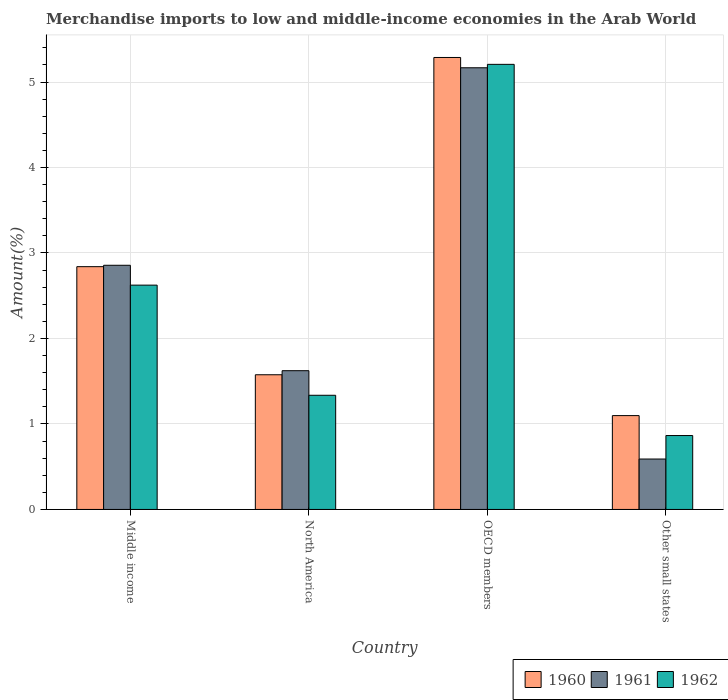How many different coloured bars are there?
Your response must be concise. 3. How many groups of bars are there?
Your answer should be compact. 4. Are the number of bars per tick equal to the number of legend labels?
Your answer should be very brief. Yes. Are the number of bars on each tick of the X-axis equal?
Offer a very short reply. Yes. What is the label of the 2nd group of bars from the left?
Make the answer very short. North America. What is the percentage of amount earned from merchandise imports in 1961 in Other small states?
Make the answer very short. 0.59. Across all countries, what is the maximum percentage of amount earned from merchandise imports in 1961?
Your response must be concise. 5.17. Across all countries, what is the minimum percentage of amount earned from merchandise imports in 1960?
Give a very brief answer. 1.1. In which country was the percentage of amount earned from merchandise imports in 1962 minimum?
Provide a short and direct response. Other small states. What is the total percentage of amount earned from merchandise imports in 1960 in the graph?
Your answer should be compact. 10.8. What is the difference between the percentage of amount earned from merchandise imports in 1961 in Middle income and that in Other small states?
Ensure brevity in your answer.  2.27. What is the difference between the percentage of amount earned from merchandise imports in 1961 in OECD members and the percentage of amount earned from merchandise imports in 1960 in Other small states?
Your answer should be compact. 4.07. What is the average percentage of amount earned from merchandise imports in 1961 per country?
Offer a very short reply. 2.56. What is the difference between the percentage of amount earned from merchandise imports of/in 1960 and percentage of amount earned from merchandise imports of/in 1962 in OECD members?
Offer a very short reply. 0.08. In how many countries, is the percentage of amount earned from merchandise imports in 1962 greater than 0.6000000000000001 %?
Provide a succinct answer. 4. What is the ratio of the percentage of amount earned from merchandise imports in 1962 in North America to that in OECD members?
Make the answer very short. 0.26. What is the difference between the highest and the second highest percentage of amount earned from merchandise imports in 1960?
Make the answer very short. -1.26. What is the difference between the highest and the lowest percentage of amount earned from merchandise imports in 1961?
Your answer should be very brief. 4.58. In how many countries, is the percentage of amount earned from merchandise imports in 1961 greater than the average percentage of amount earned from merchandise imports in 1961 taken over all countries?
Provide a short and direct response. 2. Is the sum of the percentage of amount earned from merchandise imports in 1962 in Middle income and North America greater than the maximum percentage of amount earned from merchandise imports in 1960 across all countries?
Ensure brevity in your answer.  No. What does the 3rd bar from the right in Middle income represents?
Your answer should be very brief. 1960. Is it the case that in every country, the sum of the percentage of amount earned from merchandise imports in 1962 and percentage of amount earned from merchandise imports in 1961 is greater than the percentage of amount earned from merchandise imports in 1960?
Ensure brevity in your answer.  Yes. How many bars are there?
Offer a terse response. 12. Are all the bars in the graph horizontal?
Your response must be concise. No. What is the difference between two consecutive major ticks on the Y-axis?
Provide a succinct answer. 1. Are the values on the major ticks of Y-axis written in scientific E-notation?
Your answer should be very brief. No. Does the graph contain any zero values?
Your answer should be very brief. No. Does the graph contain grids?
Offer a terse response. Yes. Where does the legend appear in the graph?
Your answer should be compact. Bottom right. How many legend labels are there?
Provide a succinct answer. 3. What is the title of the graph?
Your response must be concise. Merchandise imports to low and middle-income economies in the Arab World. Does "2004" appear as one of the legend labels in the graph?
Offer a terse response. No. What is the label or title of the Y-axis?
Make the answer very short. Amount(%). What is the Amount(%) in 1960 in Middle income?
Make the answer very short. 2.84. What is the Amount(%) of 1961 in Middle income?
Make the answer very short. 2.86. What is the Amount(%) of 1962 in Middle income?
Offer a very short reply. 2.62. What is the Amount(%) of 1960 in North America?
Offer a terse response. 1.58. What is the Amount(%) in 1961 in North America?
Your answer should be compact. 1.62. What is the Amount(%) of 1962 in North America?
Give a very brief answer. 1.34. What is the Amount(%) of 1960 in OECD members?
Give a very brief answer. 5.29. What is the Amount(%) of 1961 in OECD members?
Ensure brevity in your answer.  5.17. What is the Amount(%) of 1962 in OECD members?
Your answer should be very brief. 5.21. What is the Amount(%) in 1960 in Other small states?
Make the answer very short. 1.1. What is the Amount(%) in 1961 in Other small states?
Your answer should be very brief. 0.59. What is the Amount(%) in 1962 in Other small states?
Ensure brevity in your answer.  0.86. Across all countries, what is the maximum Amount(%) of 1960?
Your response must be concise. 5.29. Across all countries, what is the maximum Amount(%) in 1961?
Make the answer very short. 5.17. Across all countries, what is the maximum Amount(%) of 1962?
Offer a very short reply. 5.21. Across all countries, what is the minimum Amount(%) in 1960?
Make the answer very short. 1.1. Across all countries, what is the minimum Amount(%) in 1961?
Make the answer very short. 0.59. Across all countries, what is the minimum Amount(%) of 1962?
Offer a very short reply. 0.86. What is the total Amount(%) of 1960 in the graph?
Keep it short and to the point. 10.8. What is the total Amount(%) of 1961 in the graph?
Offer a very short reply. 10.24. What is the total Amount(%) in 1962 in the graph?
Keep it short and to the point. 10.03. What is the difference between the Amount(%) in 1960 in Middle income and that in North America?
Your response must be concise. 1.26. What is the difference between the Amount(%) of 1961 in Middle income and that in North America?
Give a very brief answer. 1.23. What is the difference between the Amount(%) of 1962 in Middle income and that in North America?
Ensure brevity in your answer.  1.29. What is the difference between the Amount(%) in 1960 in Middle income and that in OECD members?
Offer a very short reply. -2.45. What is the difference between the Amount(%) in 1961 in Middle income and that in OECD members?
Your answer should be compact. -2.31. What is the difference between the Amount(%) in 1962 in Middle income and that in OECD members?
Provide a short and direct response. -2.58. What is the difference between the Amount(%) in 1960 in Middle income and that in Other small states?
Provide a succinct answer. 1.74. What is the difference between the Amount(%) of 1961 in Middle income and that in Other small states?
Ensure brevity in your answer.  2.27. What is the difference between the Amount(%) of 1962 in Middle income and that in Other small states?
Give a very brief answer. 1.76. What is the difference between the Amount(%) in 1960 in North America and that in OECD members?
Offer a terse response. -3.71. What is the difference between the Amount(%) in 1961 in North America and that in OECD members?
Offer a terse response. -3.54. What is the difference between the Amount(%) in 1962 in North America and that in OECD members?
Give a very brief answer. -3.87. What is the difference between the Amount(%) of 1960 in North America and that in Other small states?
Make the answer very short. 0.48. What is the difference between the Amount(%) of 1961 in North America and that in Other small states?
Your answer should be compact. 1.03. What is the difference between the Amount(%) of 1962 in North America and that in Other small states?
Offer a very short reply. 0.47. What is the difference between the Amount(%) of 1960 in OECD members and that in Other small states?
Your answer should be compact. 4.19. What is the difference between the Amount(%) in 1961 in OECD members and that in Other small states?
Ensure brevity in your answer.  4.58. What is the difference between the Amount(%) of 1962 in OECD members and that in Other small states?
Offer a terse response. 4.34. What is the difference between the Amount(%) in 1960 in Middle income and the Amount(%) in 1961 in North America?
Your answer should be compact. 1.22. What is the difference between the Amount(%) of 1960 in Middle income and the Amount(%) of 1962 in North America?
Your answer should be compact. 1.5. What is the difference between the Amount(%) of 1961 in Middle income and the Amount(%) of 1962 in North America?
Give a very brief answer. 1.52. What is the difference between the Amount(%) in 1960 in Middle income and the Amount(%) in 1961 in OECD members?
Make the answer very short. -2.33. What is the difference between the Amount(%) in 1960 in Middle income and the Amount(%) in 1962 in OECD members?
Make the answer very short. -2.37. What is the difference between the Amount(%) in 1961 in Middle income and the Amount(%) in 1962 in OECD members?
Offer a terse response. -2.35. What is the difference between the Amount(%) of 1960 in Middle income and the Amount(%) of 1961 in Other small states?
Keep it short and to the point. 2.25. What is the difference between the Amount(%) in 1960 in Middle income and the Amount(%) in 1962 in Other small states?
Your answer should be very brief. 1.98. What is the difference between the Amount(%) of 1961 in Middle income and the Amount(%) of 1962 in Other small states?
Your response must be concise. 1.99. What is the difference between the Amount(%) of 1960 in North America and the Amount(%) of 1961 in OECD members?
Provide a short and direct response. -3.59. What is the difference between the Amount(%) in 1960 in North America and the Amount(%) in 1962 in OECD members?
Your answer should be compact. -3.63. What is the difference between the Amount(%) in 1961 in North America and the Amount(%) in 1962 in OECD members?
Offer a very short reply. -3.58. What is the difference between the Amount(%) of 1960 in North America and the Amount(%) of 1961 in Other small states?
Ensure brevity in your answer.  0.99. What is the difference between the Amount(%) of 1960 in North America and the Amount(%) of 1962 in Other small states?
Your answer should be very brief. 0.71. What is the difference between the Amount(%) of 1961 in North America and the Amount(%) of 1962 in Other small states?
Your answer should be compact. 0.76. What is the difference between the Amount(%) in 1960 in OECD members and the Amount(%) in 1961 in Other small states?
Keep it short and to the point. 4.7. What is the difference between the Amount(%) of 1960 in OECD members and the Amount(%) of 1962 in Other small states?
Offer a terse response. 4.42. What is the difference between the Amount(%) of 1961 in OECD members and the Amount(%) of 1962 in Other small states?
Make the answer very short. 4.3. What is the average Amount(%) in 1960 per country?
Keep it short and to the point. 2.7. What is the average Amount(%) of 1961 per country?
Give a very brief answer. 2.56. What is the average Amount(%) in 1962 per country?
Keep it short and to the point. 2.51. What is the difference between the Amount(%) of 1960 and Amount(%) of 1961 in Middle income?
Provide a short and direct response. -0.02. What is the difference between the Amount(%) in 1960 and Amount(%) in 1962 in Middle income?
Your answer should be compact. 0.22. What is the difference between the Amount(%) in 1961 and Amount(%) in 1962 in Middle income?
Make the answer very short. 0.23. What is the difference between the Amount(%) in 1960 and Amount(%) in 1961 in North America?
Make the answer very short. -0.05. What is the difference between the Amount(%) in 1960 and Amount(%) in 1962 in North America?
Provide a short and direct response. 0.24. What is the difference between the Amount(%) of 1961 and Amount(%) of 1962 in North America?
Provide a succinct answer. 0.29. What is the difference between the Amount(%) in 1960 and Amount(%) in 1961 in OECD members?
Offer a very short reply. 0.12. What is the difference between the Amount(%) in 1960 and Amount(%) in 1962 in OECD members?
Provide a short and direct response. 0.08. What is the difference between the Amount(%) of 1961 and Amount(%) of 1962 in OECD members?
Provide a short and direct response. -0.04. What is the difference between the Amount(%) in 1960 and Amount(%) in 1961 in Other small states?
Keep it short and to the point. 0.51. What is the difference between the Amount(%) of 1960 and Amount(%) of 1962 in Other small states?
Your response must be concise. 0.23. What is the difference between the Amount(%) of 1961 and Amount(%) of 1962 in Other small states?
Ensure brevity in your answer.  -0.27. What is the ratio of the Amount(%) of 1960 in Middle income to that in North America?
Provide a short and direct response. 1.8. What is the ratio of the Amount(%) in 1961 in Middle income to that in North America?
Your answer should be compact. 1.76. What is the ratio of the Amount(%) of 1962 in Middle income to that in North America?
Provide a short and direct response. 1.96. What is the ratio of the Amount(%) of 1960 in Middle income to that in OECD members?
Offer a very short reply. 0.54. What is the ratio of the Amount(%) in 1961 in Middle income to that in OECD members?
Offer a terse response. 0.55. What is the ratio of the Amount(%) in 1962 in Middle income to that in OECD members?
Your answer should be compact. 0.5. What is the ratio of the Amount(%) in 1960 in Middle income to that in Other small states?
Make the answer very short. 2.59. What is the ratio of the Amount(%) in 1961 in Middle income to that in Other small states?
Provide a short and direct response. 4.84. What is the ratio of the Amount(%) of 1962 in Middle income to that in Other small states?
Your response must be concise. 3.04. What is the ratio of the Amount(%) in 1960 in North America to that in OECD members?
Keep it short and to the point. 0.3. What is the ratio of the Amount(%) of 1961 in North America to that in OECD members?
Make the answer very short. 0.31. What is the ratio of the Amount(%) in 1962 in North America to that in OECD members?
Your answer should be compact. 0.26. What is the ratio of the Amount(%) of 1960 in North America to that in Other small states?
Ensure brevity in your answer.  1.44. What is the ratio of the Amount(%) in 1961 in North America to that in Other small states?
Your answer should be compact. 2.75. What is the ratio of the Amount(%) of 1962 in North America to that in Other small states?
Offer a terse response. 1.54. What is the ratio of the Amount(%) in 1960 in OECD members to that in Other small states?
Provide a succinct answer. 4.82. What is the ratio of the Amount(%) of 1961 in OECD members to that in Other small states?
Offer a very short reply. 8.76. What is the ratio of the Amount(%) of 1962 in OECD members to that in Other small states?
Your answer should be compact. 6.02. What is the difference between the highest and the second highest Amount(%) in 1960?
Make the answer very short. 2.45. What is the difference between the highest and the second highest Amount(%) in 1961?
Provide a succinct answer. 2.31. What is the difference between the highest and the second highest Amount(%) in 1962?
Your answer should be compact. 2.58. What is the difference between the highest and the lowest Amount(%) of 1960?
Provide a succinct answer. 4.19. What is the difference between the highest and the lowest Amount(%) in 1961?
Ensure brevity in your answer.  4.58. What is the difference between the highest and the lowest Amount(%) of 1962?
Your answer should be very brief. 4.34. 